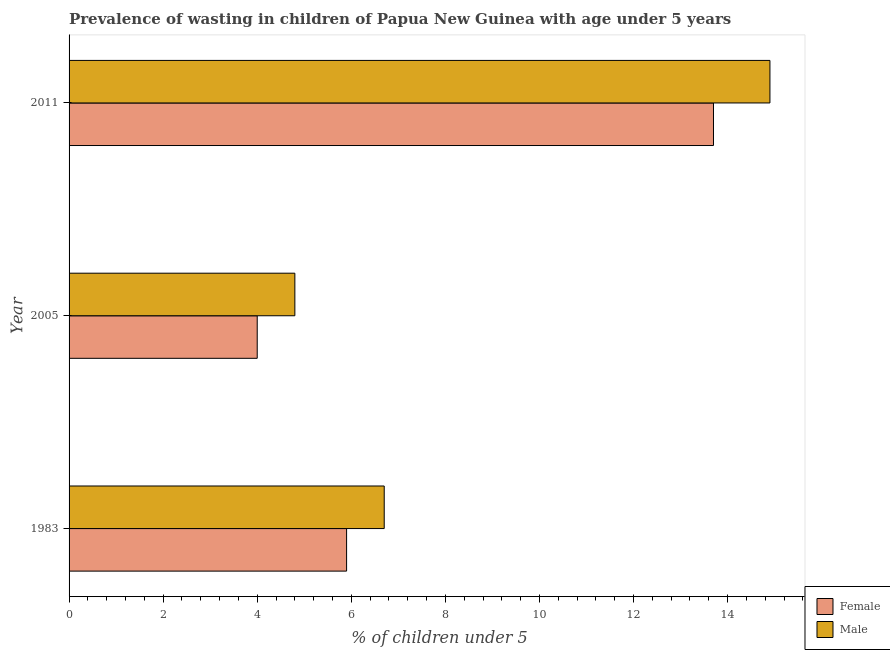How many different coloured bars are there?
Your answer should be compact. 2. How many groups of bars are there?
Offer a very short reply. 3. How many bars are there on the 1st tick from the top?
Give a very brief answer. 2. In how many cases, is the number of bars for a given year not equal to the number of legend labels?
Your response must be concise. 0. What is the percentage of undernourished female children in 2005?
Your answer should be very brief. 4. Across all years, what is the maximum percentage of undernourished male children?
Offer a very short reply. 14.9. Across all years, what is the minimum percentage of undernourished male children?
Provide a succinct answer. 4.8. What is the total percentage of undernourished female children in the graph?
Your answer should be very brief. 23.6. What is the difference between the percentage of undernourished male children in 2005 and that in 2011?
Make the answer very short. -10.1. What is the difference between the percentage of undernourished male children in 2005 and the percentage of undernourished female children in 1983?
Your answer should be very brief. -1.1. In how many years, is the percentage of undernourished female children greater than 14.8 %?
Give a very brief answer. 0. What is the ratio of the percentage of undernourished female children in 1983 to that in 2011?
Your answer should be very brief. 0.43. Is the percentage of undernourished female children in 1983 less than that in 2005?
Give a very brief answer. No. What is the difference between the highest and the lowest percentage of undernourished male children?
Keep it short and to the point. 10.1. Is the sum of the percentage of undernourished female children in 1983 and 2005 greater than the maximum percentage of undernourished male children across all years?
Keep it short and to the point. No. What does the 1st bar from the top in 2005 represents?
Offer a terse response. Male. What does the 1st bar from the bottom in 1983 represents?
Provide a succinct answer. Female. How many bars are there?
Ensure brevity in your answer.  6. Does the graph contain grids?
Make the answer very short. No. How many legend labels are there?
Make the answer very short. 2. How are the legend labels stacked?
Offer a very short reply. Vertical. What is the title of the graph?
Offer a terse response. Prevalence of wasting in children of Papua New Guinea with age under 5 years. What is the label or title of the X-axis?
Your answer should be compact.  % of children under 5. What is the  % of children under 5 of Female in 1983?
Ensure brevity in your answer.  5.9. What is the  % of children under 5 in Male in 1983?
Make the answer very short. 6.7. What is the  % of children under 5 of Female in 2005?
Make the answer very short. 4. What is the  % of children under 5 in Male in 2005?
Your answer should be compact. 4.8. What is the  % of children under 5 in Female in 2011?
Your answer should be compact. 13.7. What is the  % of children under 5 of Male in 2011?
Provide a short and direct response. 14.9. Across all years, what is the maximum  % of children under 5 in Female?
Offer a terse response. 13.7. Across all years, what is the maximum  % of children under 5 of Male?
Provide a succinct answer. 14.9. Across all years, what is the minimum  % of children under 5 in Male?
Ensure brevity in your answer.  4.8. What is the total  % of children under 5 in Female in the graph?
Offer a very short reply. 23.6. What is the total  % of children under 5 in Male in the graph?
Your answer should be very brief. 26.4. What is the difference between the  % of children under 5 of Male in 1983 and that in 2011?
Offer a terse response. -8.2. What is the difference between the  % of children under 5 in Male in 2005 and that in 2011?
Give a very brief answer. -10.1. What is the difference between the  % of children under 5 of Female in 1983 and the  % of children under 5 of Male in 2011?
Your response must be concise. -9. What is the average  % of children under 5 of Female per year?
Make the answer very short. 7.87. What is the average  % of children under 5 in Male per year?
Offer a very short reply. 8.8. In the year 2005, what is the difference between the  % of children under 5 in Female and  % of children under 5 in Male?
Keep it short and to the point. -0.8. What is the ratio of the  % of children under 5 in Female in 1983 to that in 2005?
Make the answer very short. 1.48. What is the ratio of the  % of children under 5 of Male in 1983 to that in 2005?
Make the answer very short. 1.4. What is the ratio of the  % of children under 5 in Female in 1983 to that in 2011?
Make the answer very short. 0.43. What is the ratio of the  % of children under 5 in Male in 1983 to that in 2011?
Give a very brief answer. 0.45. What is the ratio of the  % of children under 5 in Female in 2005 to that in 2011?
Your answer should be very brief. 0.29. What is the ratio of the  % of children under 5 in Male in 2005 to that in 2011?
Give a very brief answer. 0.32. What is the difference between the highest and the second highest  % of children under 5 in Female?
Make the answer very short. 7.8. What is the difference between the highest and the lowest  % of children under 5 in Male?
Your answer should be very brief. 10.1. 